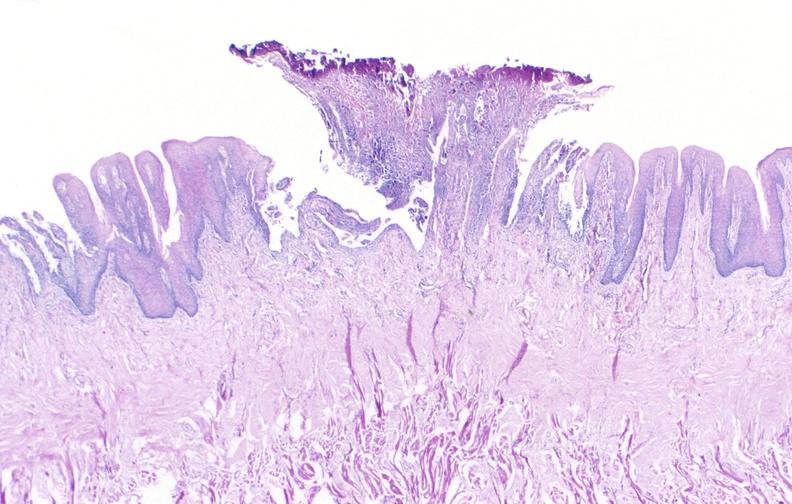s gastrointestinal present?
Answer the question using a single word or phrase. Yes 